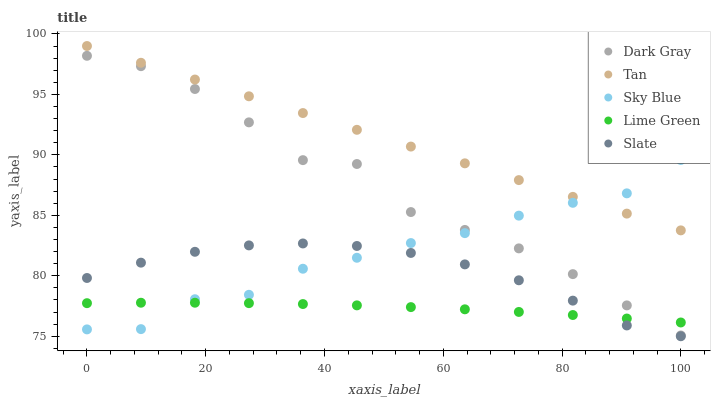Does Lime Green have the minimum area under the curve?
Answer yes or no. Yes. Does Tan have the maximum area under the curve?
Answer yes or no. Yes. Does Sky Blue have the minimum area under the curve?
Answer yes or no. No. Does Sky Blue have the maximum area under the curve?
Answer yes or no. No. Is Tan the smoothest?
Answer yes or no. Yes. Is Dark Gray the roughest?
Answer yes or no. Yes. Is Sky Blue the smoothest?
Answer yes or no. No. Is Sky Blue the roughest?
Answer yes or no. No. Does Slate have the lowest value?
Answer yes or no. Yes. Does Sky Blue have the lowest value?
Answer yes or no. No. Does Tan have the highest value?
Answer yes or no. Yes. Does Sky Blue have the highest value?
Answer yes or no. No. Is Slate less than Tan?
Answer yes or no. Yes. Is Dark Gray greater than Slate?
Answer yes or no. Yes. Does Dark Gray intersect Lime Green?
Answer yes or no. Yes. Is Dark Gray less than Lime Green?
Answer yes or no. No. Is Dark Gray greater than Lime Green?
Answer yes or no. No. Does Slate intersect Tan?
Answer yes or no. No. 